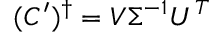Convert formula to latex. <formula><loc_0><loc_0><loc_500><loc_500>( C ^ { \prime } ) ^ { \dag } = V \Sigma ^ { - 1 } U ^ { T }</formula> 